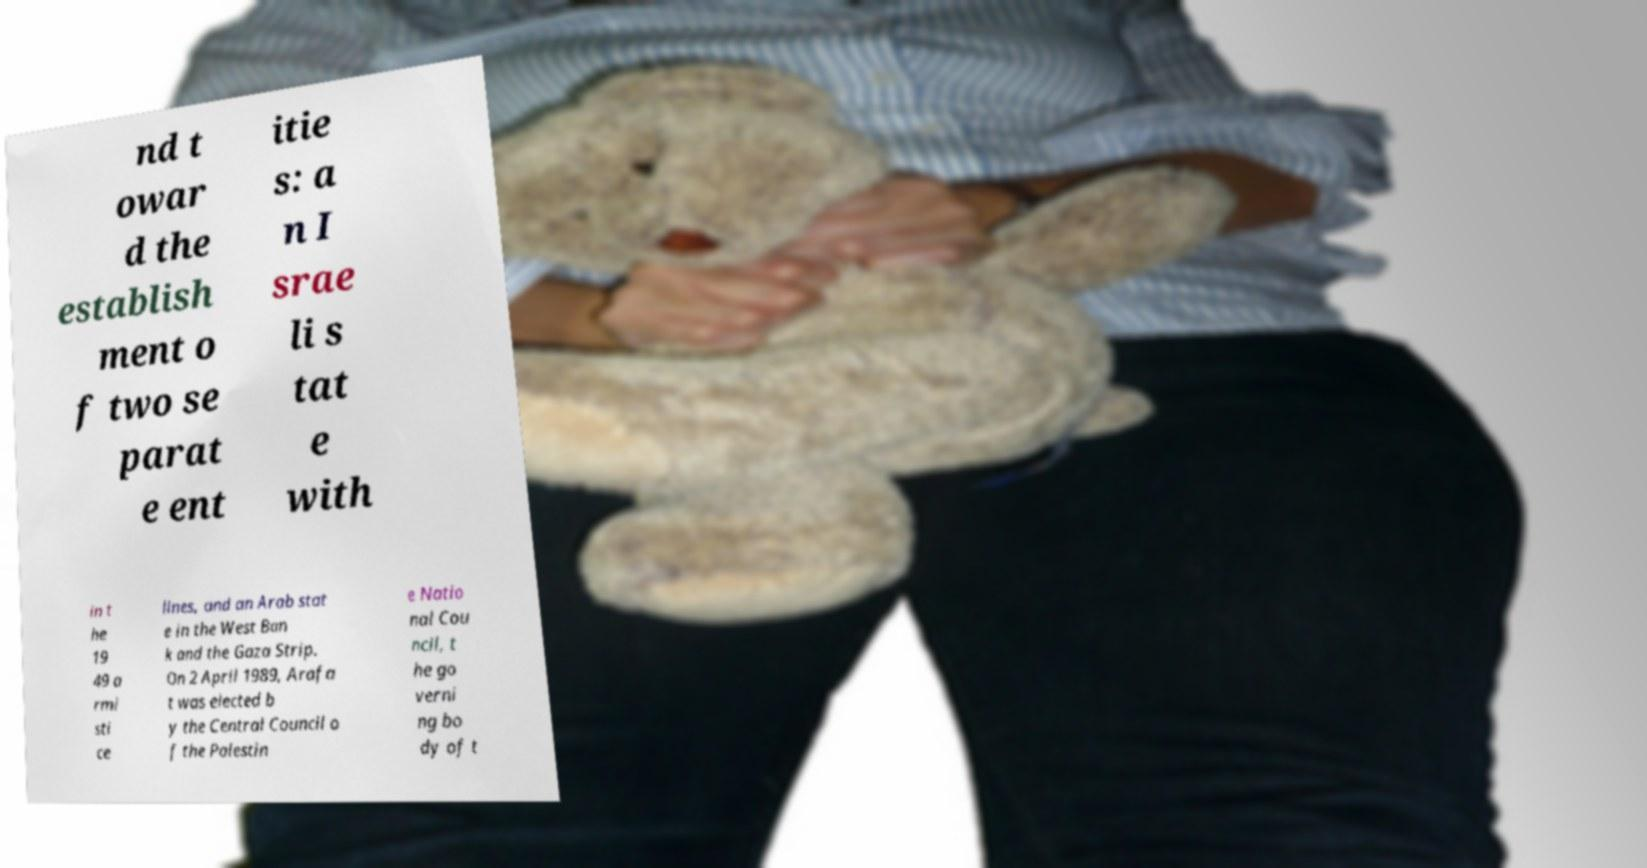I need the written content from this picture converted into text. Can you do that? nd t owar d the establish ment o f two se parat e ent itie s: a n I srae li s tat e with in t he 19 49 a rmi sti ce lines, and an Arab stat e in the West Ban k and the Gaza Strip. On 2 April 1989, Arafa t was elected b y the Central Council o f the Palestin e Natio nal Cou ncil, t he go verni ng bo dy of t 